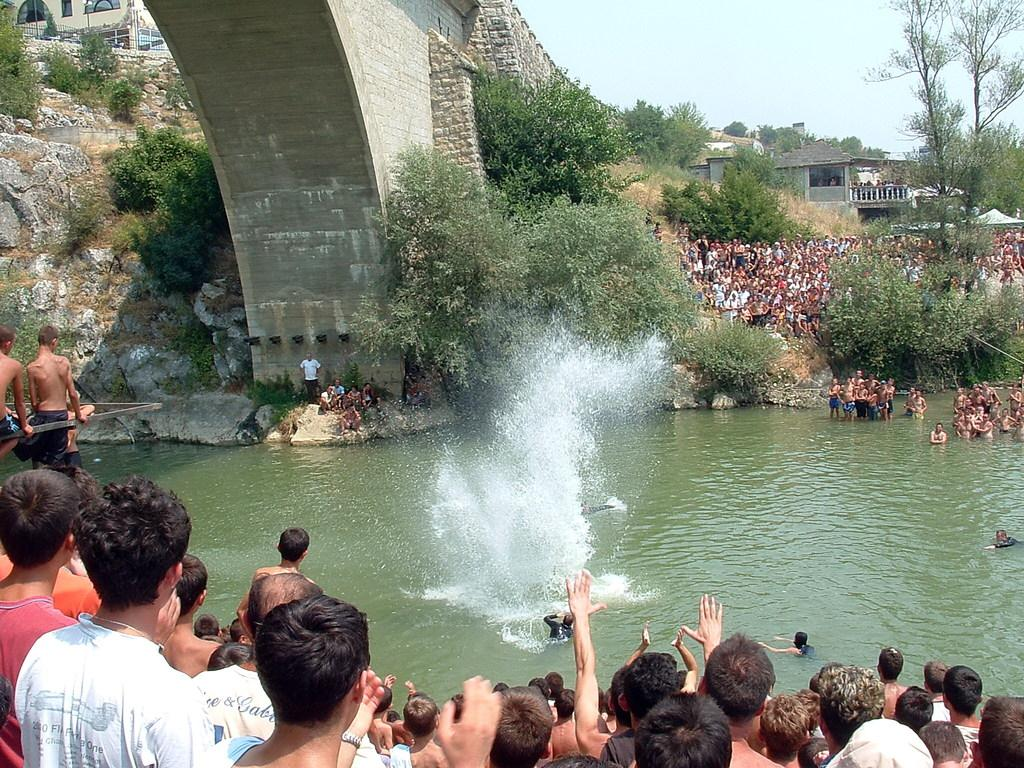Who or what can be seen in the image? There are people in the image. What type of structures are present in the image? There are houses in the image. What type of vegetation is visible in the image? There are trees and plants in the image. What natural element can be seen in the image? There is water visible in the image. What type of man-made structure is present in the image? There is a bridge in the image. What part of the natural environment is visible in the image? The sky is visible in the image. What type of ground surface is present in the image? There are stones in the image. What type of bun is being served at the manager's meeting in the image? There is no mention of a bun or a manager's meeting in the image. What date is marked on the calendar in the image? There is no calendar present in the image. 